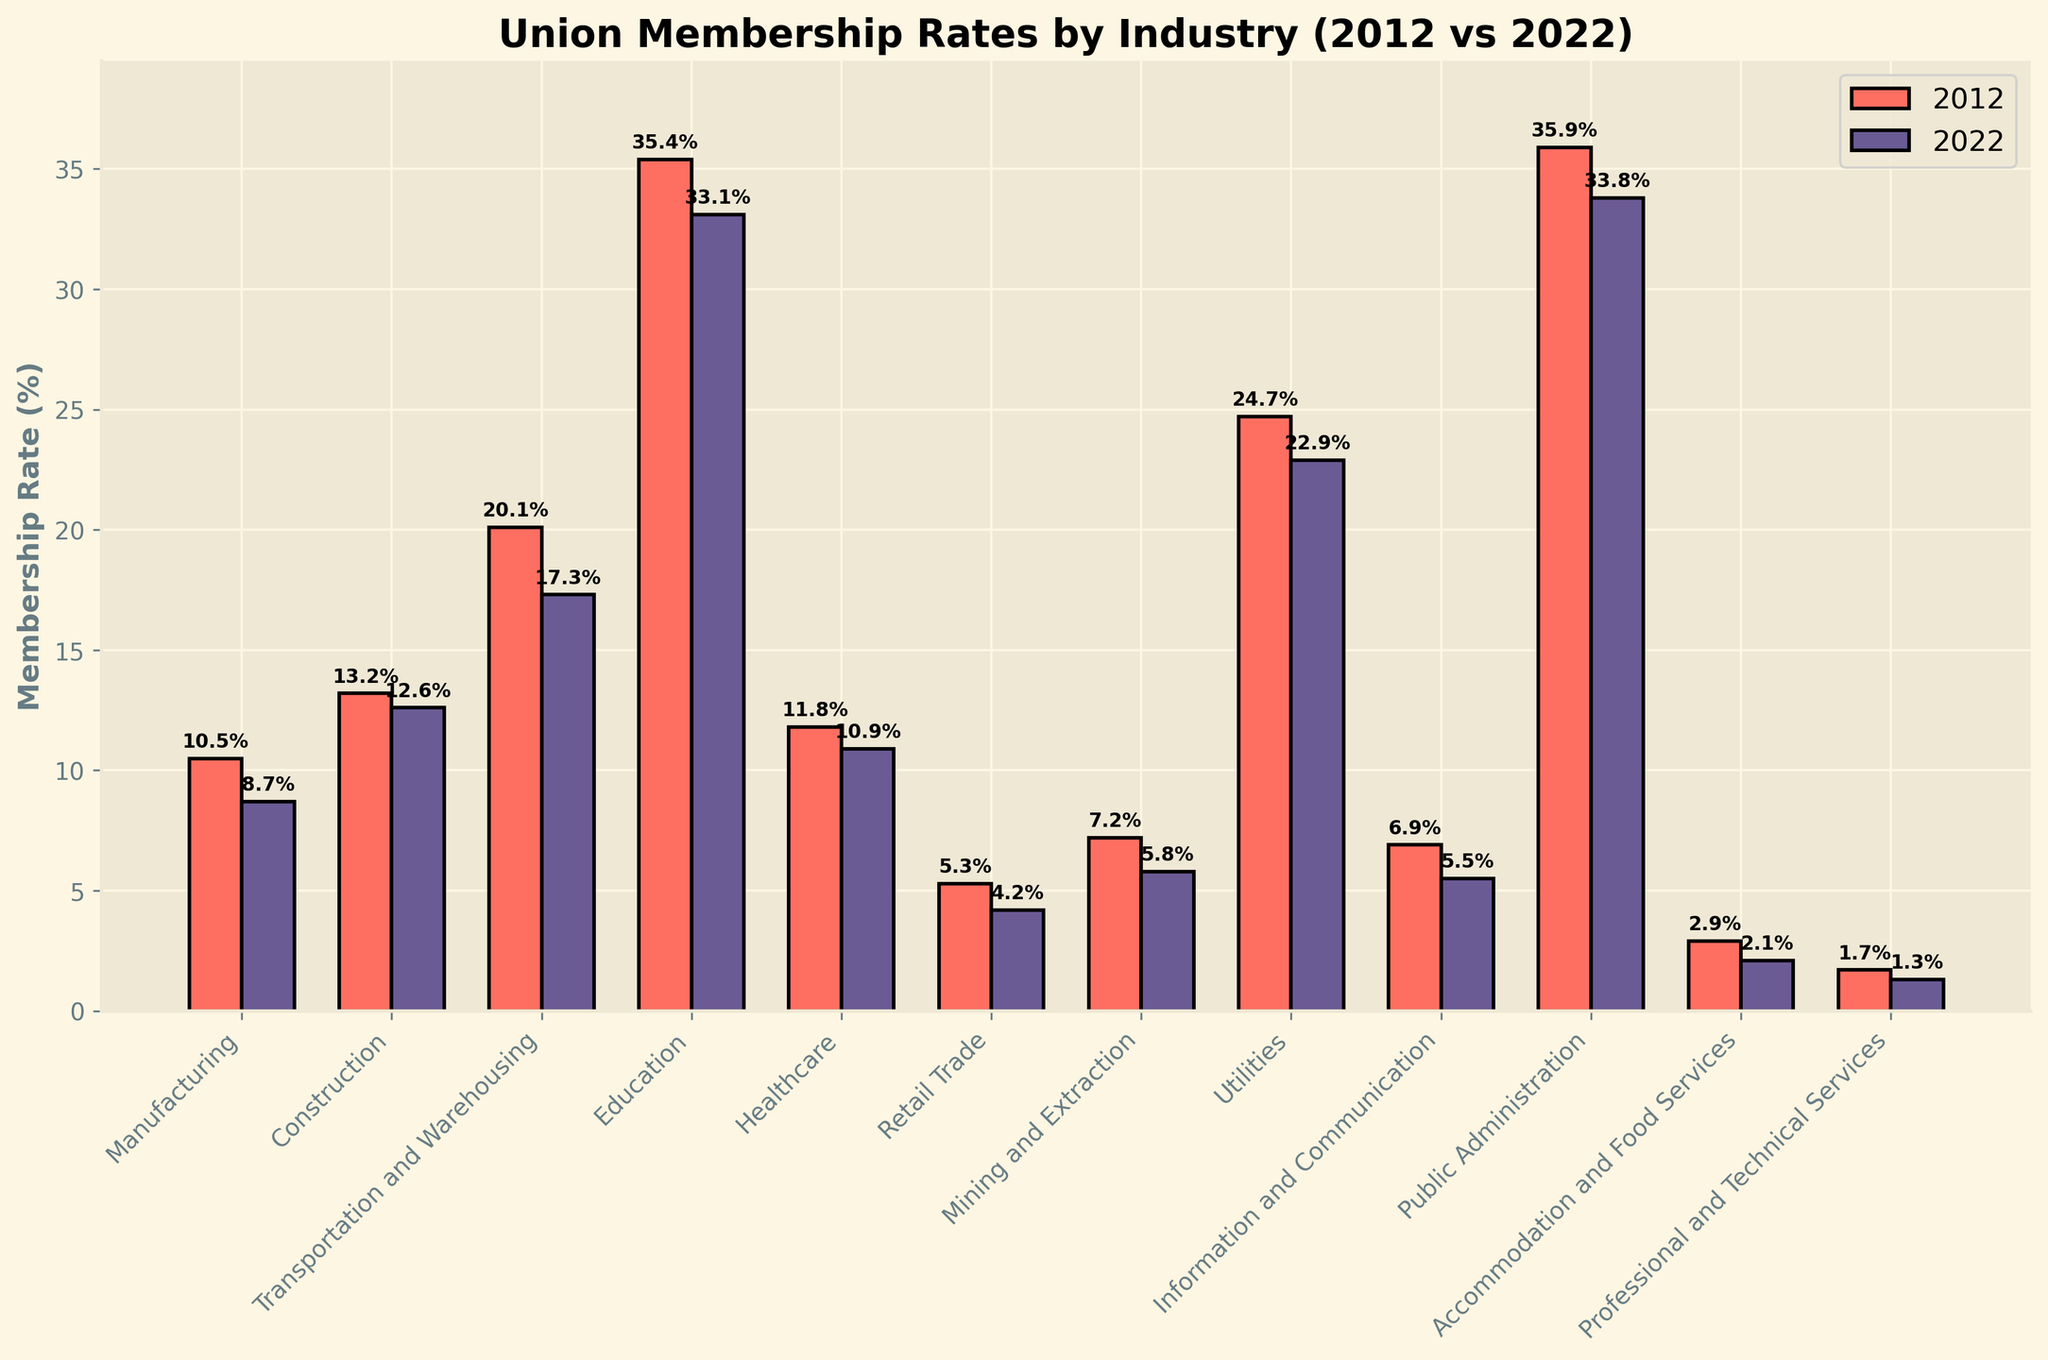How much did union membership rates in the Transportation and Warehousing industry decrease from 2012 to 2022? Look at the height of the bars for Transportation and Warehousing in both 2012 and 2022. Subtract the 2022 value (17.3) from the 2012 value (20.1).
Answer: 2.8% Which industry had the highest union membership rate in 2022? Compare the heights of the 2022 bars for all industries. Public Administration has the highest bar.
Answer: Public Administration Did union membership increase or decrease in the Healthcare industry from 2012 to 2022? Compare the heights of the bars for Healthcare in both 2012 and 2022. The bar for 2022 is lower than the bar for 2012, indicating a decrease.
Answer: Decrease How many industries had a decrease in union membership rates from 2012 to 2022? Count the industries where the 2022 bar height is lower than the 2012 bar height. There are 9 such industries: Manufacturing, Transportation and Warehousing, Education, Healthcare, Retail Trade, Mining and Extraction, Utilities, Information and Communication, and Public Administration.
Answer: 9 In which industry was the union membership rate closest to 10% in 2022? Look at the heights of the bars for all industries in 2022 and identify which one is closest to 10%. Manufacturing is closest, with a rate of 8.7%.
Answer: Manufacturing By how much did union membership rates for the Utilities industry change between 2012 and 2022? Look at the heights of the bars for Utilities in both 2012 and 2022. Subtract the 2022 value (22.9) from the 2012 value (24.7).
Answer: 1.8% Which industry had the smallest union membership rate in both 2012 and 2022? Compare the heights of the bars for all industries in 2012 and 2022. Professional and Technical Services had the smallest membership rate in both years.
Answer: Professional and Technical Services What is the average union membership rate across all industries for 2022? Add the 2022 values for all industries and divide by the number of industries (12). Sum: 8.7 + 12.6 + 17.3 + 33.1 + 10.9 + 4.2 + 5.8 + 22.9 + 5.5 + 33.8 + 2.1 + 1.3 = 158.2. Average: 158.2 / 12 ≈ 13.2.
Answer: 13.2% 